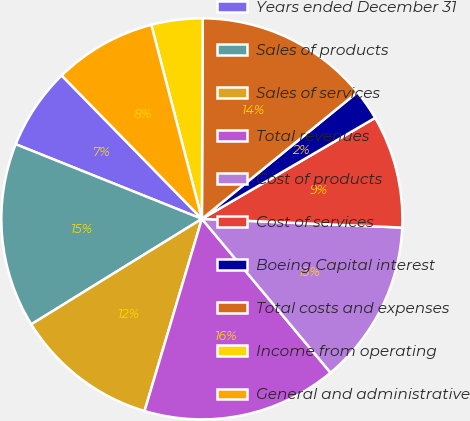Convert chart to OTSL. <chart><loc_0><loc_0><loc_500><loc_500><pie_chart><fcel>Years ended December 31<fcel>Sales of products<fcel>Sales of services<fcel>Total revenues<fcel>Cost of products<fcel>Cost of services<fcel>Boeing Capital interest<fcel>Total costs and expenses<fcel>Income from operating<fcel>General and administrative<nl><fcel>6.61%<fcel>14.88%<fcel>11.57%<fcel>15.7%<fcel>13.22%<fcel>9.09%<fcel>2.48%<fcel>14.05%<fcel>4.13%<fcel>8.26%<nl></chart> 